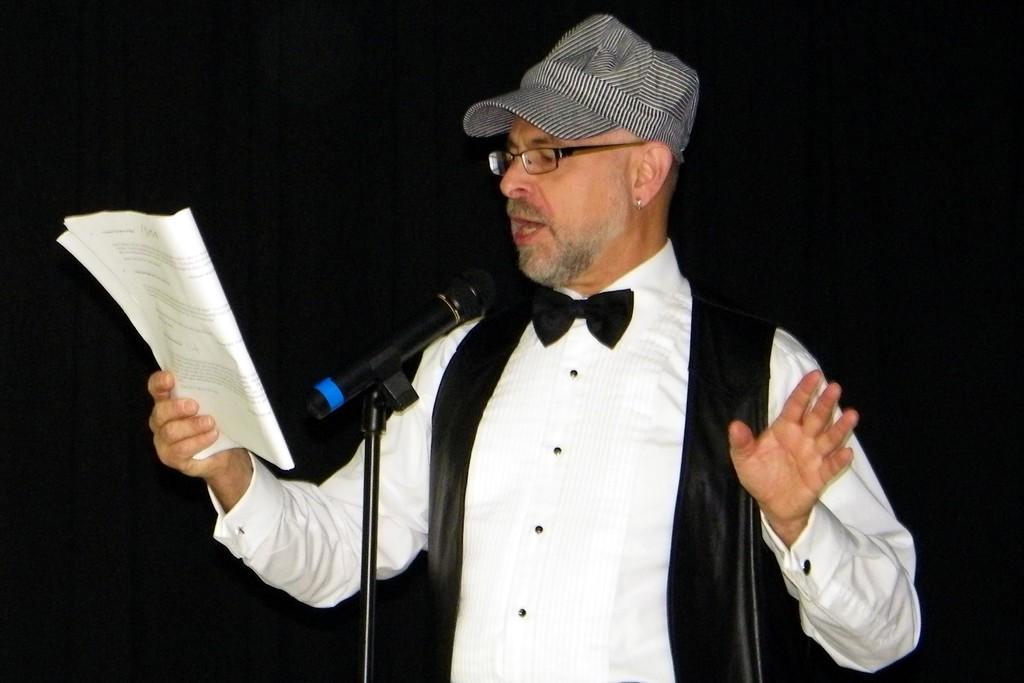In one or two sentences, can you explain what this image depicts? Here I can see a man wearing white color shirt, cap on the head, holding a book in the hand and looking into the book. In front of this man I can see a mike stand. It seems like he is singing. The background is in black color. 